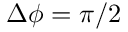<formula> <loc_0><loc_0><loc_500><loc_500>\Delta \phi = \pi / 2</formula> 